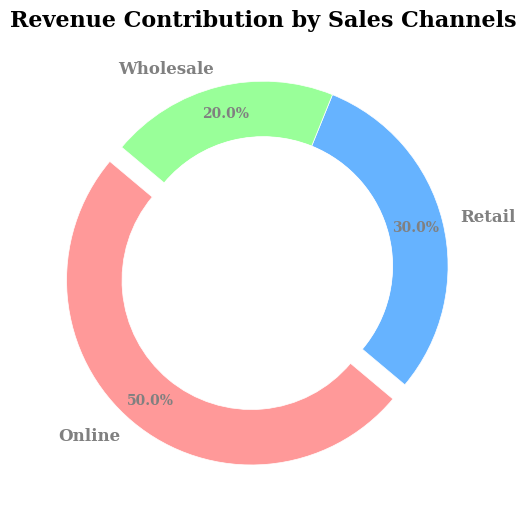What percentage of the revenue does the Online channel contribute? The Online channel contributes 500,000 out of the total 1,000,000. Dividing 500,000 by 1,000,000 and multiplying by 100 gives 50.0%.
Answer: 50.0% Which channel contributes the least to the overall revenue? By looking at the pie chart, the section labeled Wholesale is the smallest segment, indicating it has the least revenue contribution.
Answer: Wholesale What is the combined revenue contribution of the Retail and Wholesale channels? The Retail channel contributes 300,000 and the Wholesale channel contributes 200,000. Their combined contribution is 300,000 + 200,000, which equals 500,000.
Answer: 500,000 How does the revenue contribution of the Retail channel compare to the Wholesale channel? The Retail channel contributes 300,000, while the Wholesale channel contributes 200,000. The Retail channel's contribution is higher by 100,000.
Answer: The Retail channel contributes more What is the approximate size difference in percentage points between the Online and Retail channels? The Online channel contributes 50.0%, while the Retail channel contributes 30.0%. The difference in their contributions is 50.0% - 30.0%, which is 20.0 percentage points.
Answer: 20.0 percentage points Which sales channel is represented by the segment in red? In the description of the figure, the red color is associated with the Online channel. Thus, the red segment represents the Online sales channel.
Answer: Online How much more does the Wholesale channel need to match the Online channel's revenue contribution? The Online channel contributes 500,000, while the Wholesale channel contributes 200,000. The difference between them is 500,000 - 200,000, which equals 300,000.
Answer: 300,000 By how much percentage does the Retail channel's contribution exceed that of the Wholesale channel? The Retail channel contributes 30.0% and the Wholesale channel 20.0%. The percentage that Retail exceeds Wholesale is 30.0% - 20.0%, which is 10.0%.
Answer: 10.0% What coloring pattern is used for the Retail channel, and what insight does it provide? The Retail channel is colored blue, making it easy to identify its contribution of 30.0% in the pie chart.
Answer: Blue What's the average revenue contribution across the three channels? Summing the contributions, we have 500,000 (Online) + 300,000 (Retail) + 200,000 (Wholesale) = 1,000,000. Dividing by the 3 channels, the average is 1,000,000 / 3, which equals approximately 333,333.33.
Answer: Approximately 333,333.33 